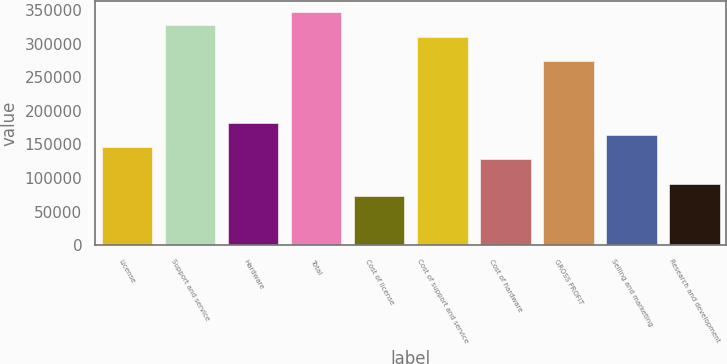Convert chart to OTSL. <chart><loc_0><loc_0><loc_500><loc_500><bar_chart><fcel>License<fcel>Support and service<fcel>Hardware<fcel>Total<fcel>Cost of license<fcel>Cost of support and service<fcel>Cost of hardware<fcel>GROSS PROFIT<fcel>Selling and marketing<fcel>Research and development<nl><fcel>145865<fcel>328196<fcel>182331<fcel>346429<fcel>72932.6<fcel>309962<fcel>127632<fcel>273496<fcel>164098<fcel>91165.7<nl></chart> 